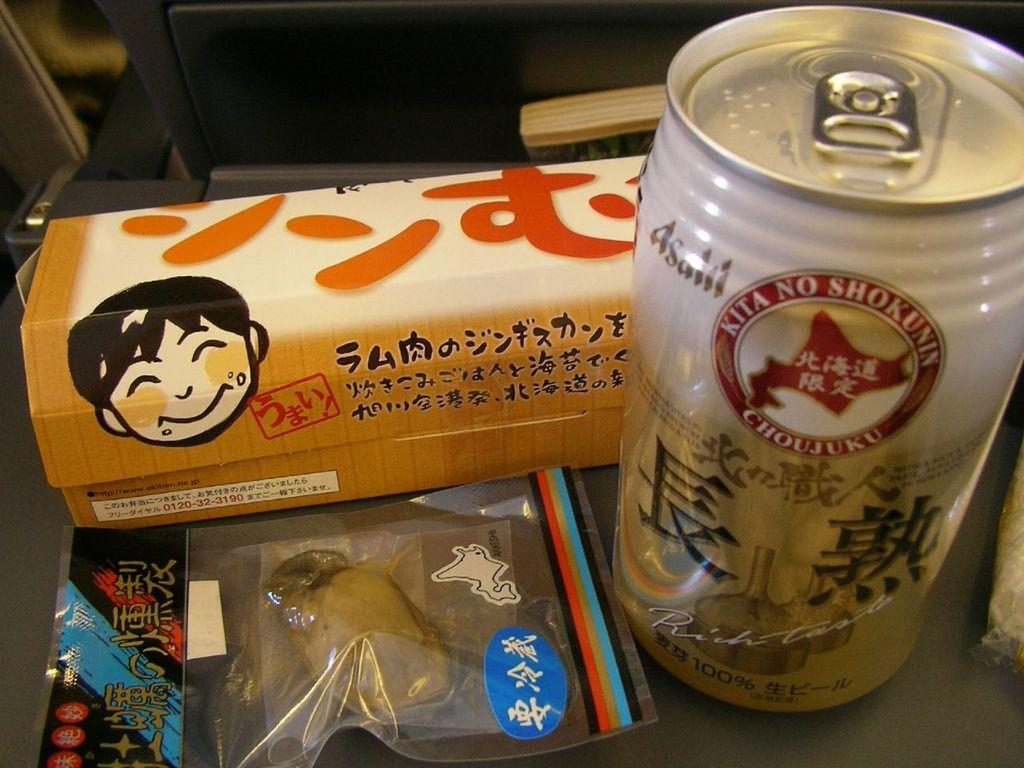<image>
Relay a brief, clear account of the picture shown. Japanese snacks and drink including Asailil can which says Kita No Shokunin on the side. 